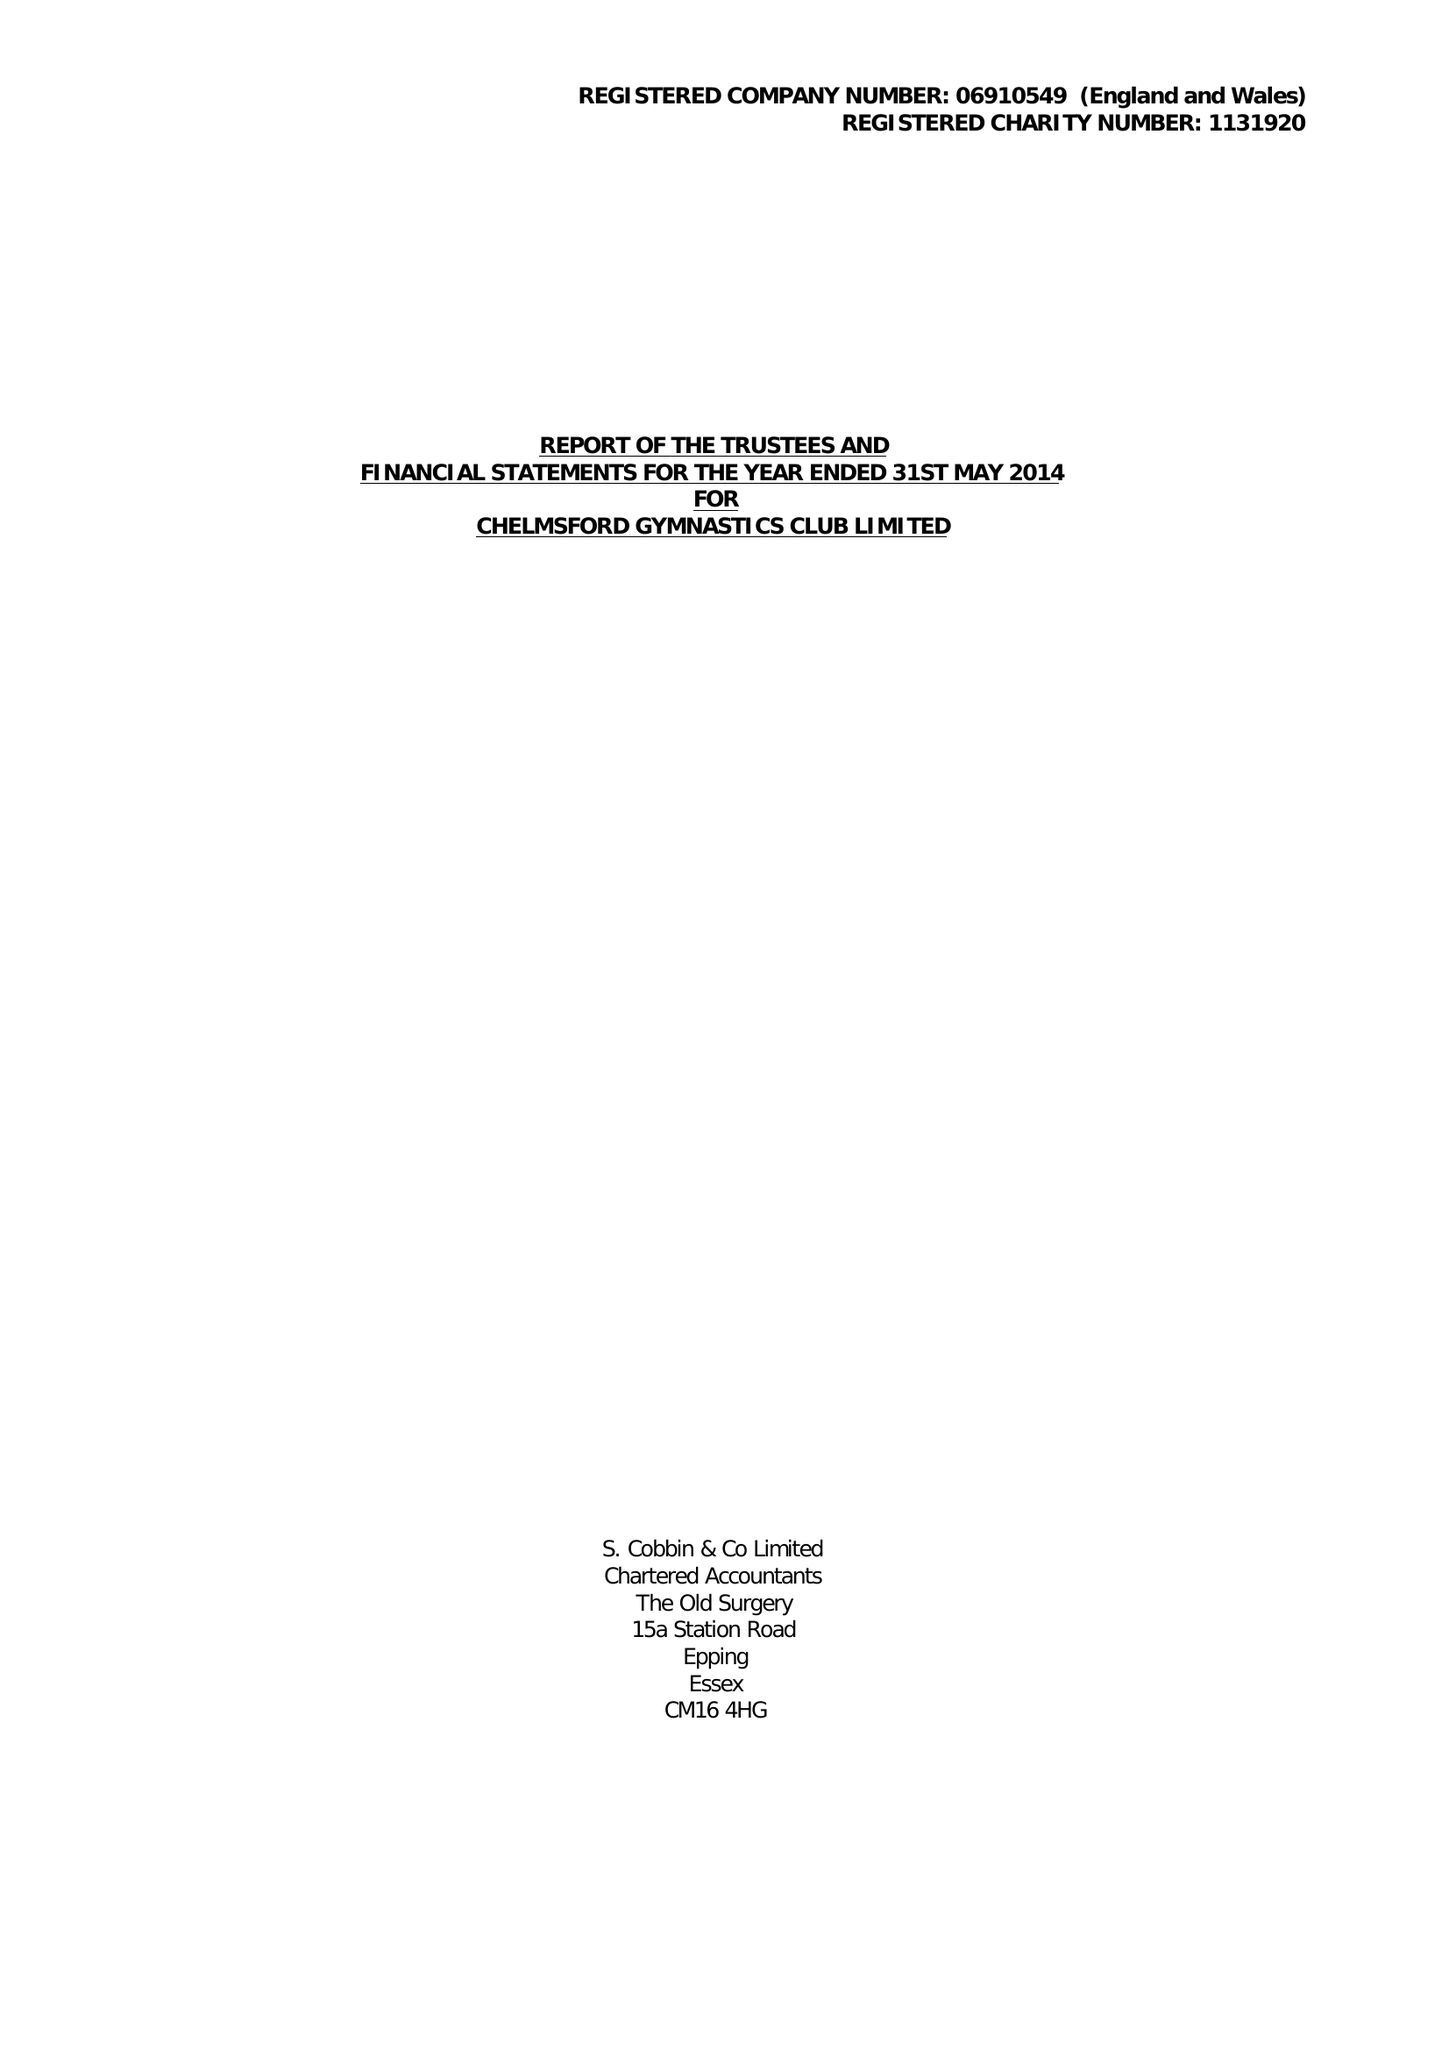What is the value for the charity_name?
Answer the question using a single word or phrase. Chelmsford Gymnastics Club Ltd. 